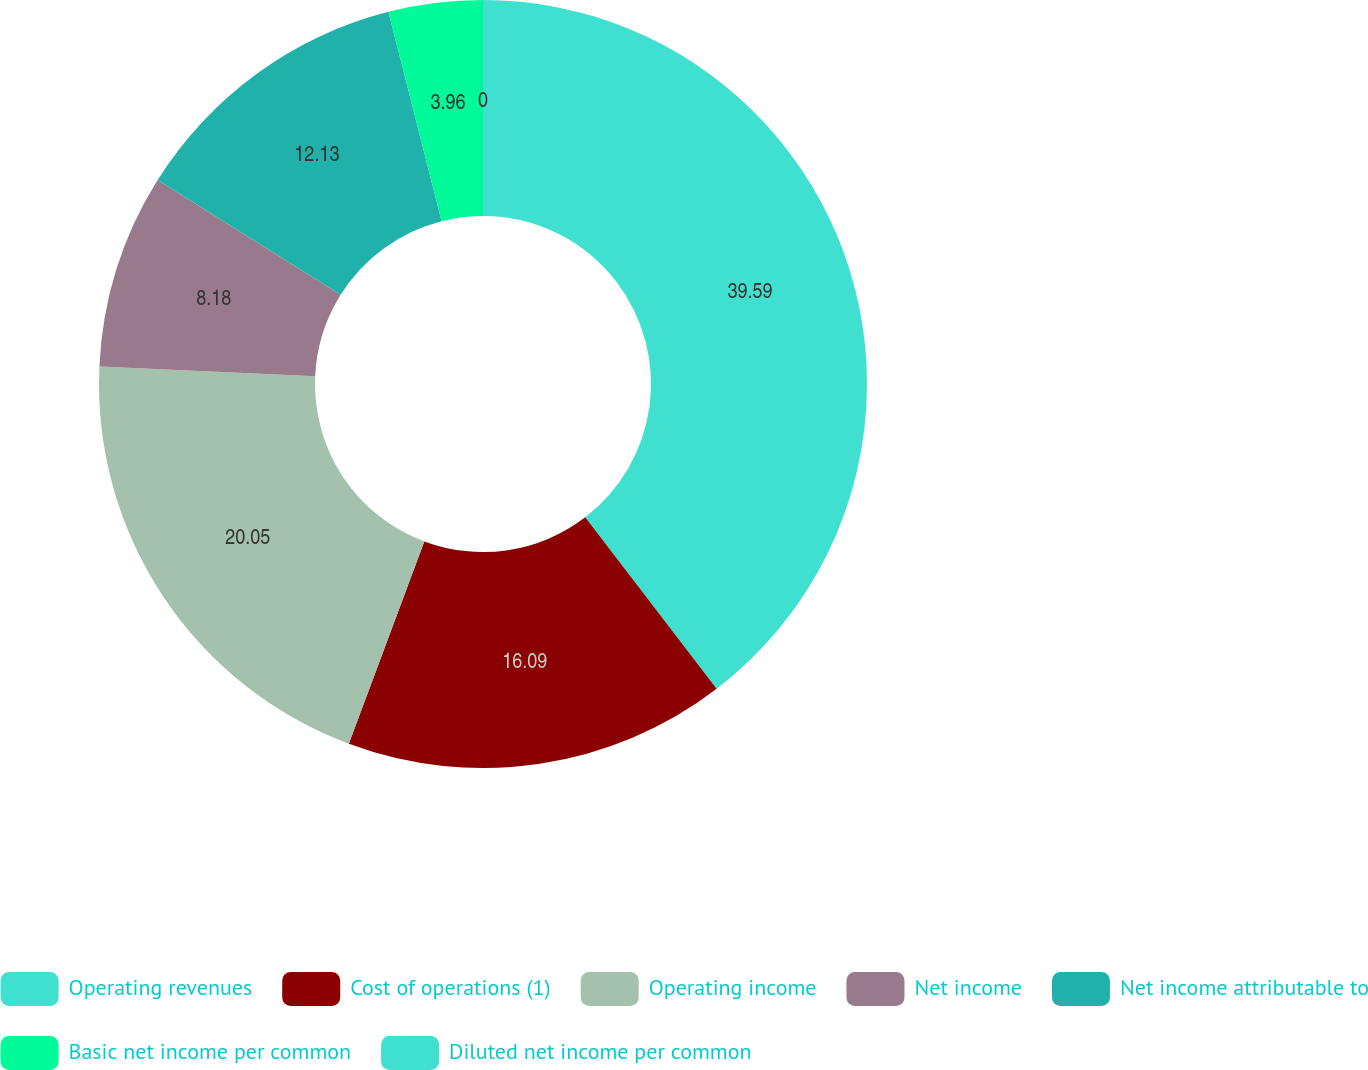Convert chart to OTSL. <chart><loc_0><loc_0><loc_500><loc_500><pie_chart><fcel>Operating revenues<fcel>Cost of operations (1)<fcel>Operating income<fcel>Net income<fcel>Net income attributable to<fcel>Basic net income per common<fcel>Diluted net income per common<nl><fcel>39.59%<fcel>16.09%<fcel>20.05%<fcel>8.18%<fcel>12.13%<fcel>3.96%<fcel>0.0%<nl></chart> 